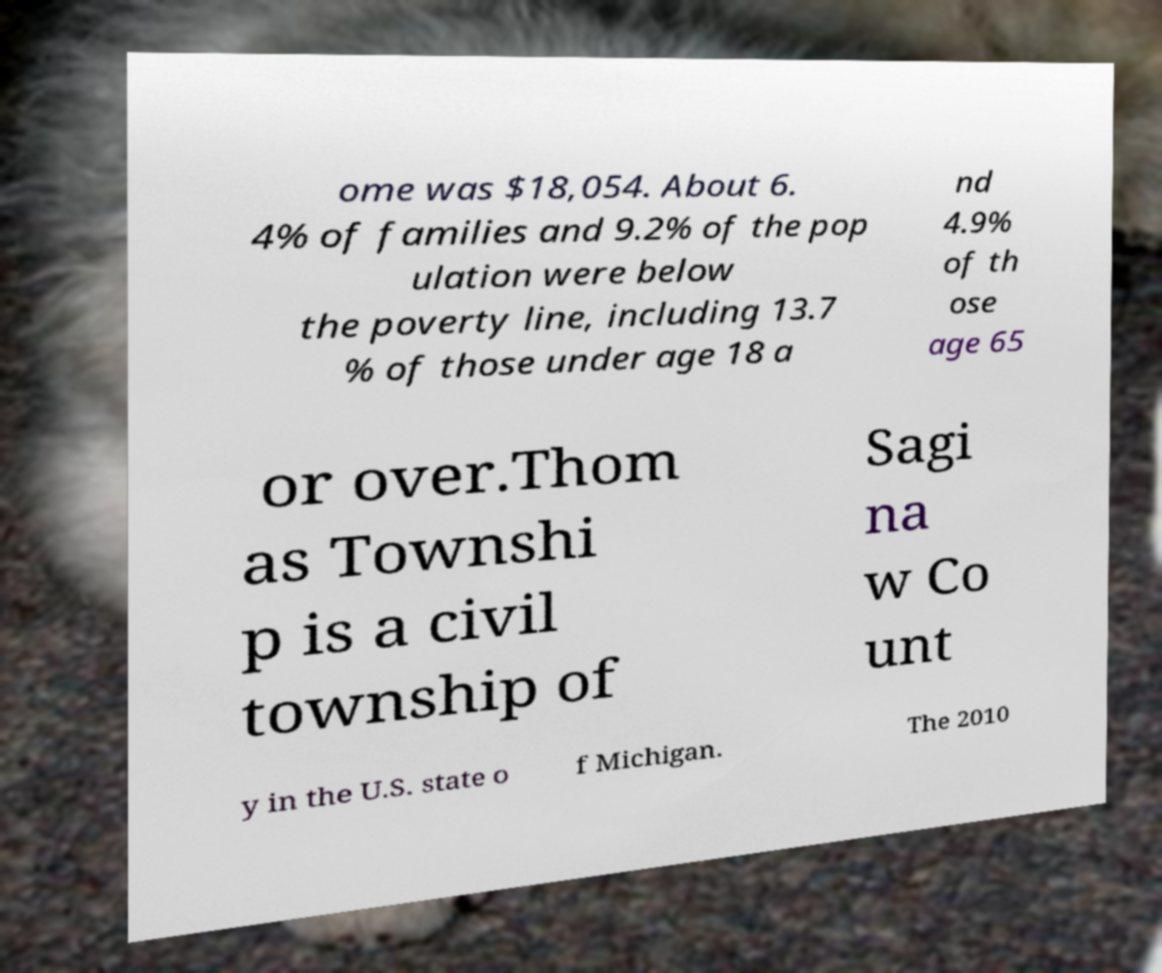Please read and relay the text visible in this image. What does it say? ome was $18,054. About 6. 4% of families and 9.2% of the pop ulation were below the poverty line, including 13.7 % of those under age 18 a nd 4.9% of th ose age 65 or over.Thom as Townshi p is a civil township of Sagi na w Co unt y in the U.S. state o f Michigan. The 2010 